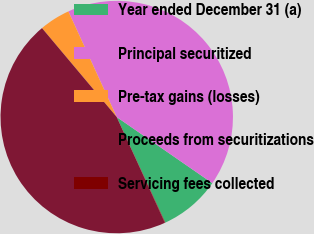Convert chart to OTSL. <chart><loc_0><loc_0><loc_500><loc_500><pie_chart><fcel>Year ended December 31 (a)<fcel>Principal securitized<fcel>Pre-tax gains (losses)<fcel>Proceeds from securitizations<fcel>Servicing fees collected<nl><fcel>8.51%<fcel>41.46%<fcel>4.29%<fcel>45.68%<fcel>0.06%<nl></chart> 